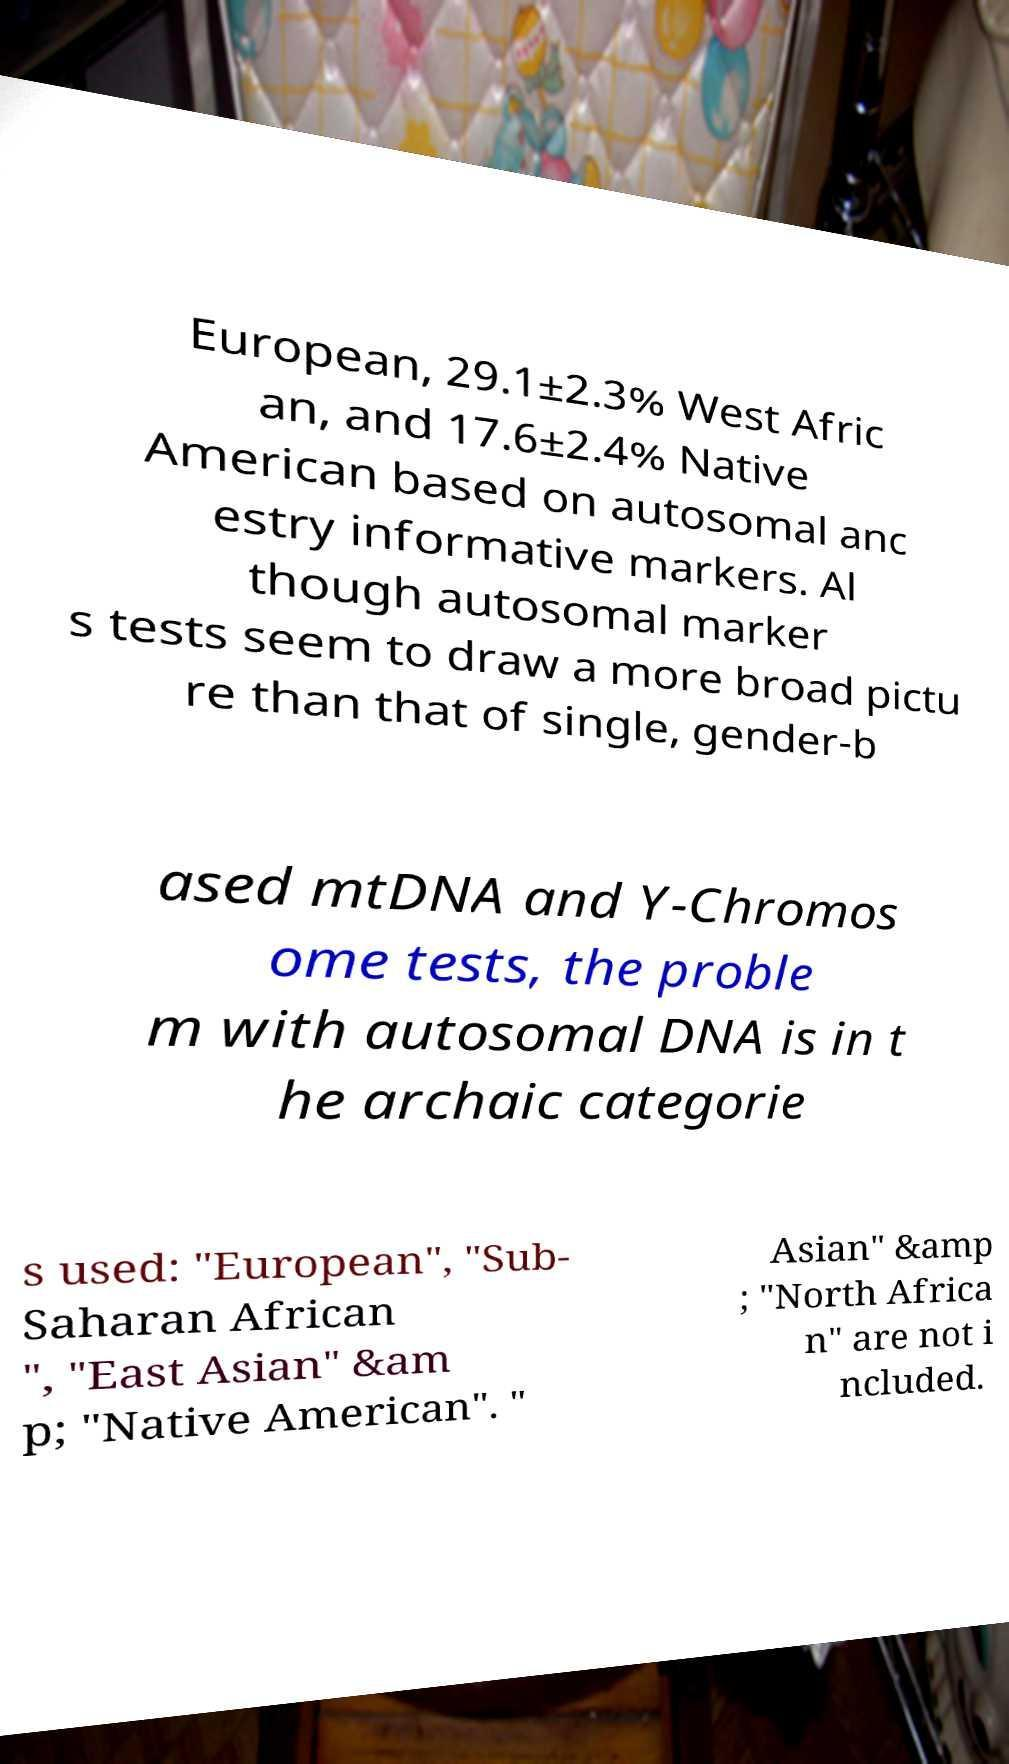What messages or text are displayed in this image? I need them in a readable, typed format. European, 29.1±2.3% West Afric an, and 17.6±2.4% Native American based on autosomal anc estry informative markers. Al though autosomal marker s tests seem to draw a more broad pictu re than that of single, gender-b ased mtDNA and Y-Chromos ome tests, the proble m with autosomal DNA is in t he archaic categorie s used: "European", "Sub- Saharan African ", "East Asian" &am p; "Native American". " Asian" &amp ; "North Africa n" are not i ncluded. 